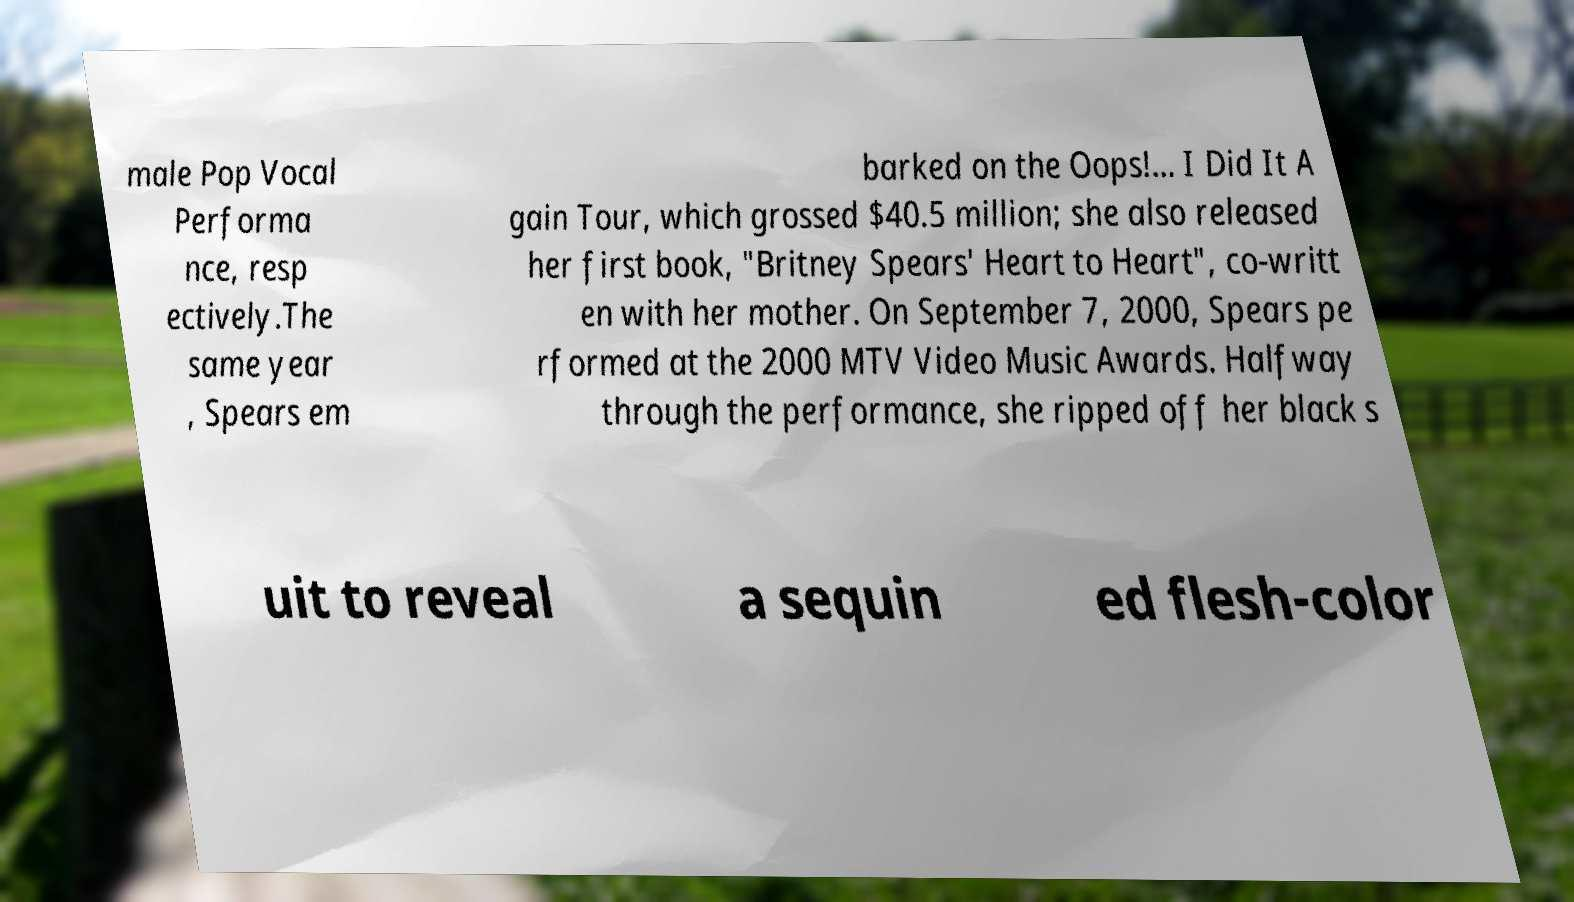Could you extract and type out the text from this image? male Pop Vocal Performa nce, resp ectively.The same year , Spears em barked on the Oops!... I Did It A gain Tour, which grossed $40.5 million; she also released her first book, "Britney Spears' Heart to Heart", co-writt en with her mother. On September 7, 2000, Spears pe rformed at the 2000 MTV Video Music Awards. Halfway through the performance, she ripped off her black s uit to reveal a sequin ed flesh-color 